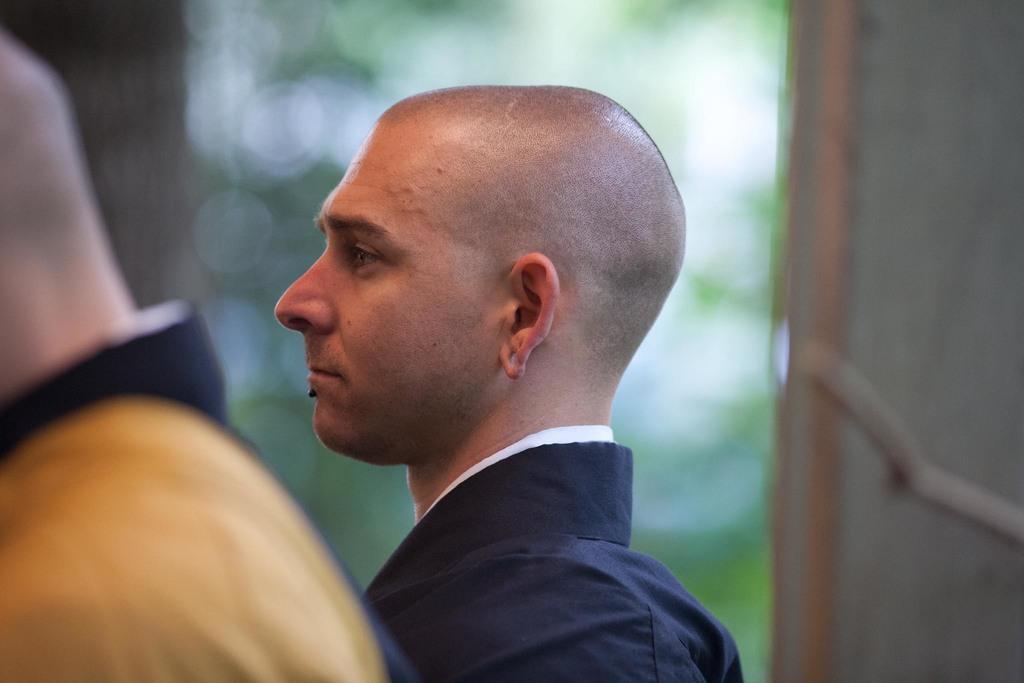Could you give a brief overview of what you see in this image? In this image, I can see two people. The background looks blurry. I think this is the wall. 